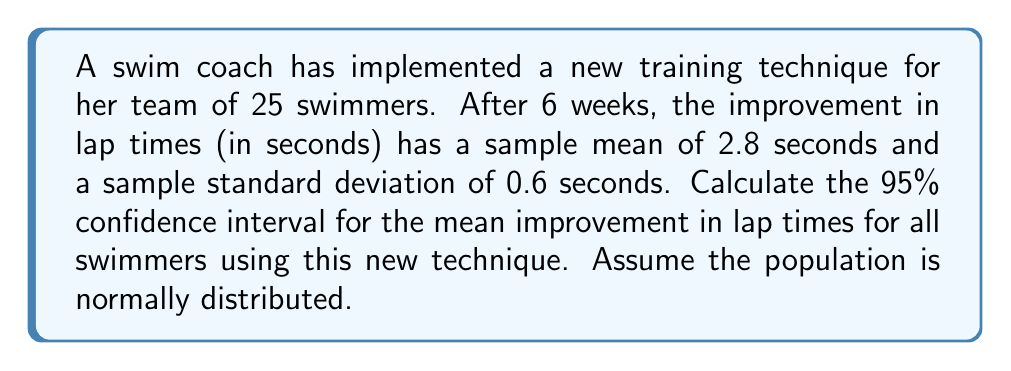Give your solution to this math problem. To calculate the confidence interval for the mean, we'll use the formula:

$$ \text{CI} = \bar{x} \pm t_{\frac{\alpha}{2}, n-1} \cdot \frac{s}{\sqrt{n}} $$

Where:
$\bar{x}$ = sample mean = 2.8 seconds
$s$ = sample standard deviation = 0.6 seconds
$n$ = sample size = 25
$\alpha$ = 1 - confidence level = 1 - 0.95 = 0.05
$t_{\frac{\alpha}{2}, n-1}$ = t-value for 95% confidence level with 24 degrees of freedom

Steps:
1) Find the t-value: $t_{0.025, 24} = 2.064$ (from t-distribution table)

2) Calculate the margin of error:
   $$ \text{Margin of Error} = t_{0.025, 24} \cdot \frac{s}{\sqrt{n}} = 2.064 \cdot \frac{0.6}{\sqrt{25}} = 0.2477 $$

3) Calculate the confidence interval:
   $$ \text{CI} = 2.8 \pm 0.2477 $$
   $$ \text{Lower bound} = 2.8 - 0.2477 = 2.5523 $$
   $$ \text{Upper bound} = 2.8 + 0.2477 = 3.0477 $$

Therefore, we are 95% confident that the true mean improvement in lap times for all swimmers using this new technique is between 2.5523 and 3.0477 seconds.
Answer: (2.5523, 3.0477) seconds 